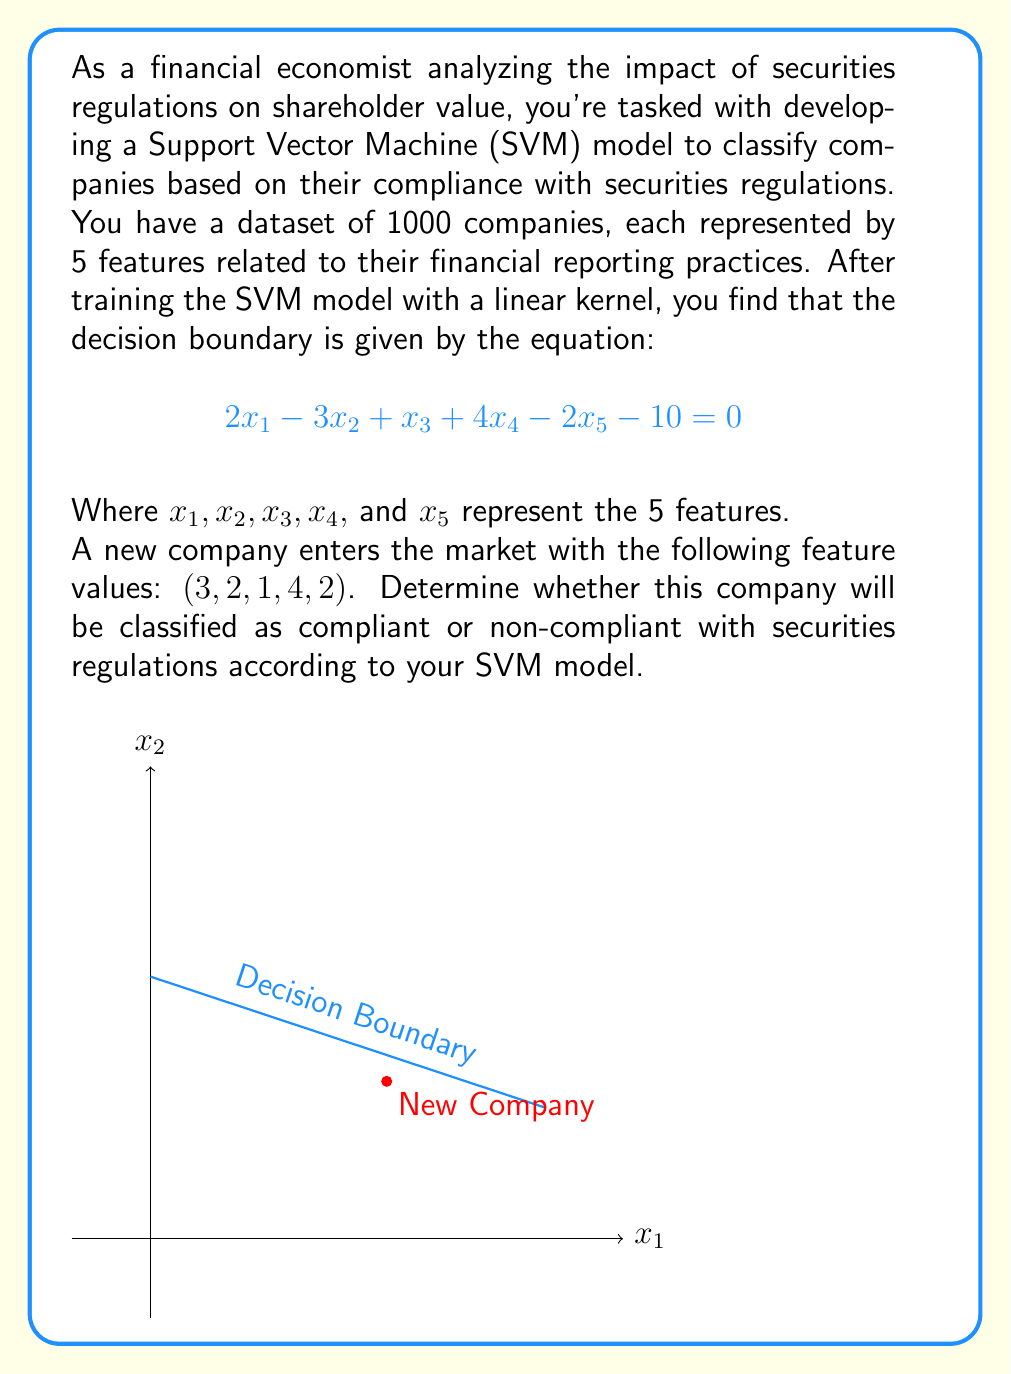Could you help me with this problem? To determine the classification of the new company, we need to follow these steps:

1) Recall that in an SVM with a linear kernel, the decision boundary is represented by the hyperplane equation:

   $$w^T x + b = 0$$

   where $w$ is the normal vector to the hyperplane, $x$ is the input vector, and $b$ is the bias term.

2) In our case, the hyperplane equation is:

   $$2x_1 - 3x_2 + x_3 + 4x_4 - 2x_5 - 10 = 0$$

3) To classify a new point, we need to evaluate the left side of this equation with the given feature values. If the result is positive, the point is on one side of the hyperplane; if negative, it's on the other side.

4) Let's substitute the values for the new company $(3, 2, 1, 4, 2)$ into the equation:

   $$2(3) - 3(2) + 1(1) + 4(4) - 2(2) - 10$$

5) Simplify:

   $$6 - 6 + 1 + 16 - 4 - 10 = 3$$

6) The result is positive (3 > 0), which means the new company is on the positive side of the hyperplane.

7) In SVM classification, one side of the hyperplane represents one class, and the other side represents the other class. Typically, the positive side is associated with the compliant class in binary classification tasks.

Therefore, based on this SVM model, the new company would be classified as compliant with securities regulations.
Answer: Compliant 